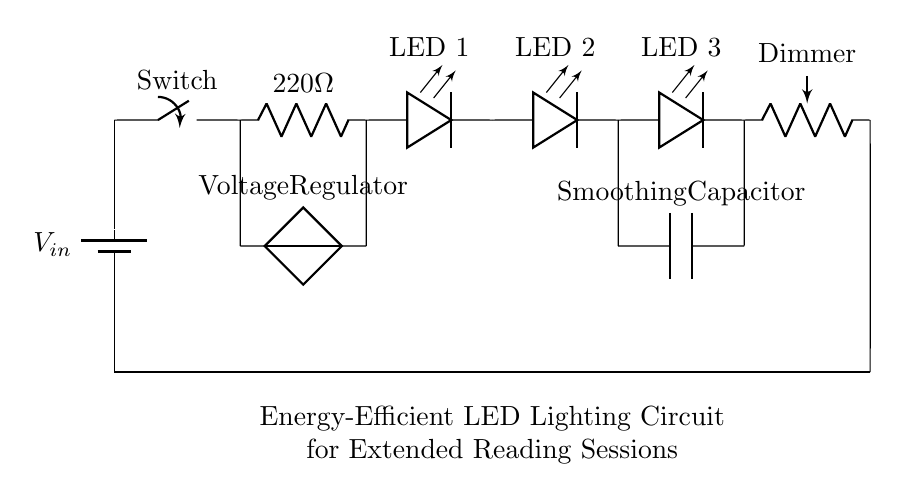What is the input voltage for the circuit? The input voltage is labeled as V_in, which represents the voltage supplied to the circuit from the battery.
Answer: V_in What is the resistance value of the current-limiting resistor? The current-limiting resistor is indicated on the diagram with a label of 220 ohms, providing the value required to limit the current flowing to the LEDs.
Answer: 220 ohms How many LEDs are present in this circuit? The circuit diagram shows three separate LEDs connected in series, making it easy to count each LED indicated by their individual labels.
Answer: 3 What component is used for dimming the lights? The component indicated as "Dimmer" in the diagram is a potentiometer, which allows the adjustment of brightness by varying resistance.
Answer: Dimmer How does the circuit maintain energy efficiency? The circuit maintains energy efficiency through the inclusion of a voltage regulator and a smoothing capacitor, which stabilize the voltage and reduce energy loss, thereby optimizing performance.
Answer: Voltage regulator and smoothing capacitor What is the purpose of the switch in the circuit? The switch is used to open or close the circuit, enabling users to turn the lighting on or off as needed during reading or writing sessions, providing user control over the lighting.
Answer: Control power 